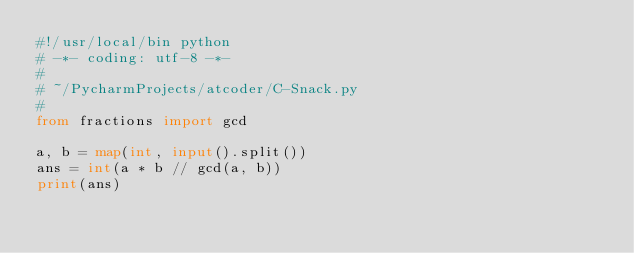Convert code to text. <code><loc_0><loc_0><loc_500><loc_500><_Python_>#!/usr/local/bin python
# -*- coding: utf-8 -*-
#
# ~/PycharmProjects/atcoder/C-Snack.py
#
from fractions import gcd

a, b = map(int, input().split())
ans = int(a * b // gcd(a, b))
print(ans)
</code> 